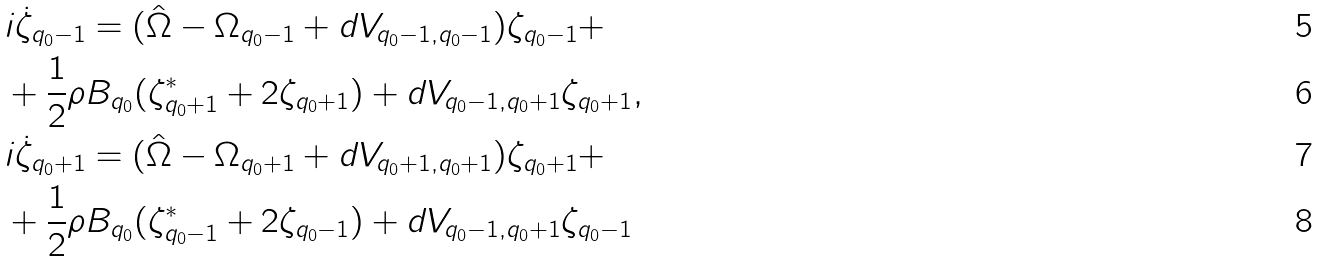Convert formula to latex. <formula><loc_0><loc_0><loc_500><loc_500>& i \dot { \zeta } _ { q _ { 0 } - 1 } = ( \hat { \Omega } - \Omega _ { q _ { 0 } - 1 } + d V _ { q _ { 0 } - 1 , q _ { 0 } - 1 } ) \zeta _ { q _ { 0 } - 1 } + \\ & + \frac { 1 } { 2 } \rho B _ { q _ { 0 } } ( \zeta _ { q _ { 0 } + 1 } ^ { * } + 2 \zeta _ { q _ { 0 } + 1 } ) + d V _ { q _ { 0 } - 1 , q _ { 0 } + 1 } \zeta _ { q _ { 0 } + 1 } , \\ & i \dot { \zeta } _ { q _ { 0 } + 1 } = ( \hat { \Omega } - \Omega _ { q _ { 0 } + 1 } + d V _ { q _ { 0 } + 1 , q _ { 0 } + 1 } ) \zeta _ { q _ { 0 } + 1 } + \\ & + \frac { 1 } { 2 } \rho B _ { q _ { 0 } } ( \zeta _ { q _ { 0 } - 1 } ^ { * } + 2 \zeta _ { q _ { 0 } - 1 } ) + d V _ { q _ { 0 } - 1 , q _ { 0 } + 1 } \zeta _ { q _ { 0 } - 1 }</formula> 